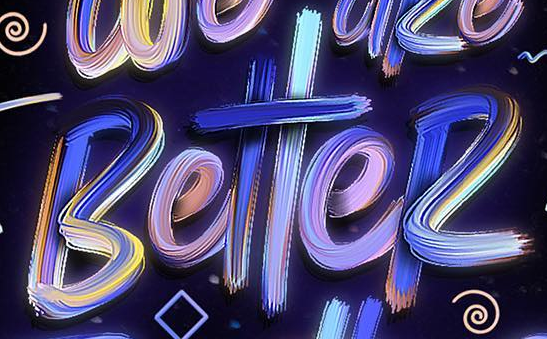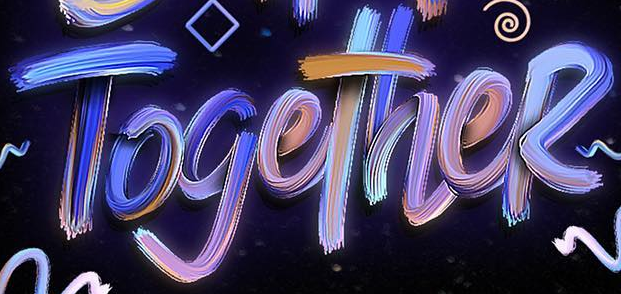What text is displayed in these images sequentially, separated by a semicolon? BetteR; TogetheR 